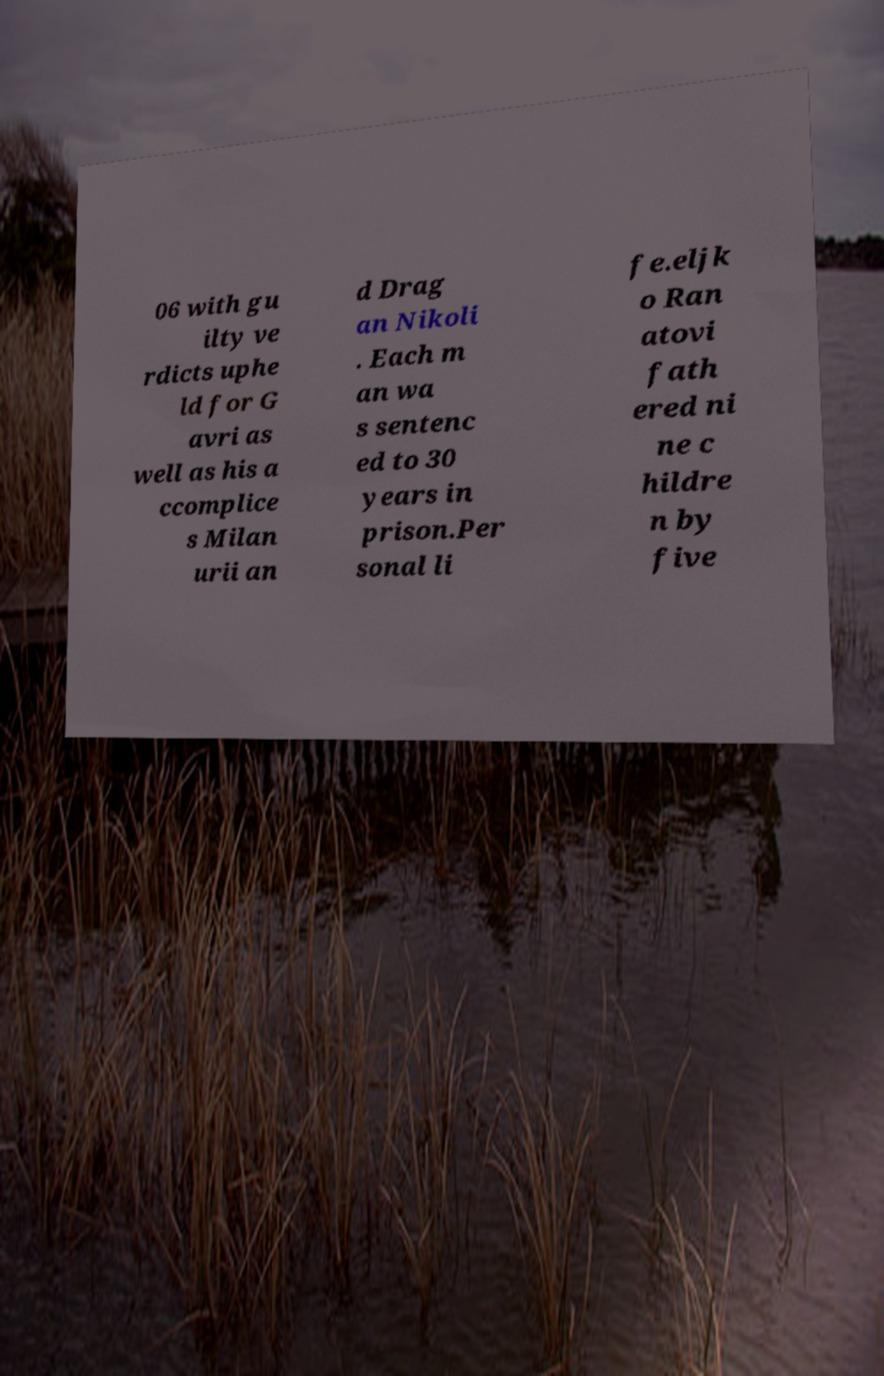There's text embedded in this image that I need extracted. Can you transcribe it verbatim? 06 with gu ilty ve rdicts uphe ld for G avri as well as his a ccomplice s Milan urii an d Drag an Nikoli . Each m an wa s sentenc ed to 30 years in prison.Per sonal li fe.eljk o Ran atovi fath ered ni ne c hildre n by five 